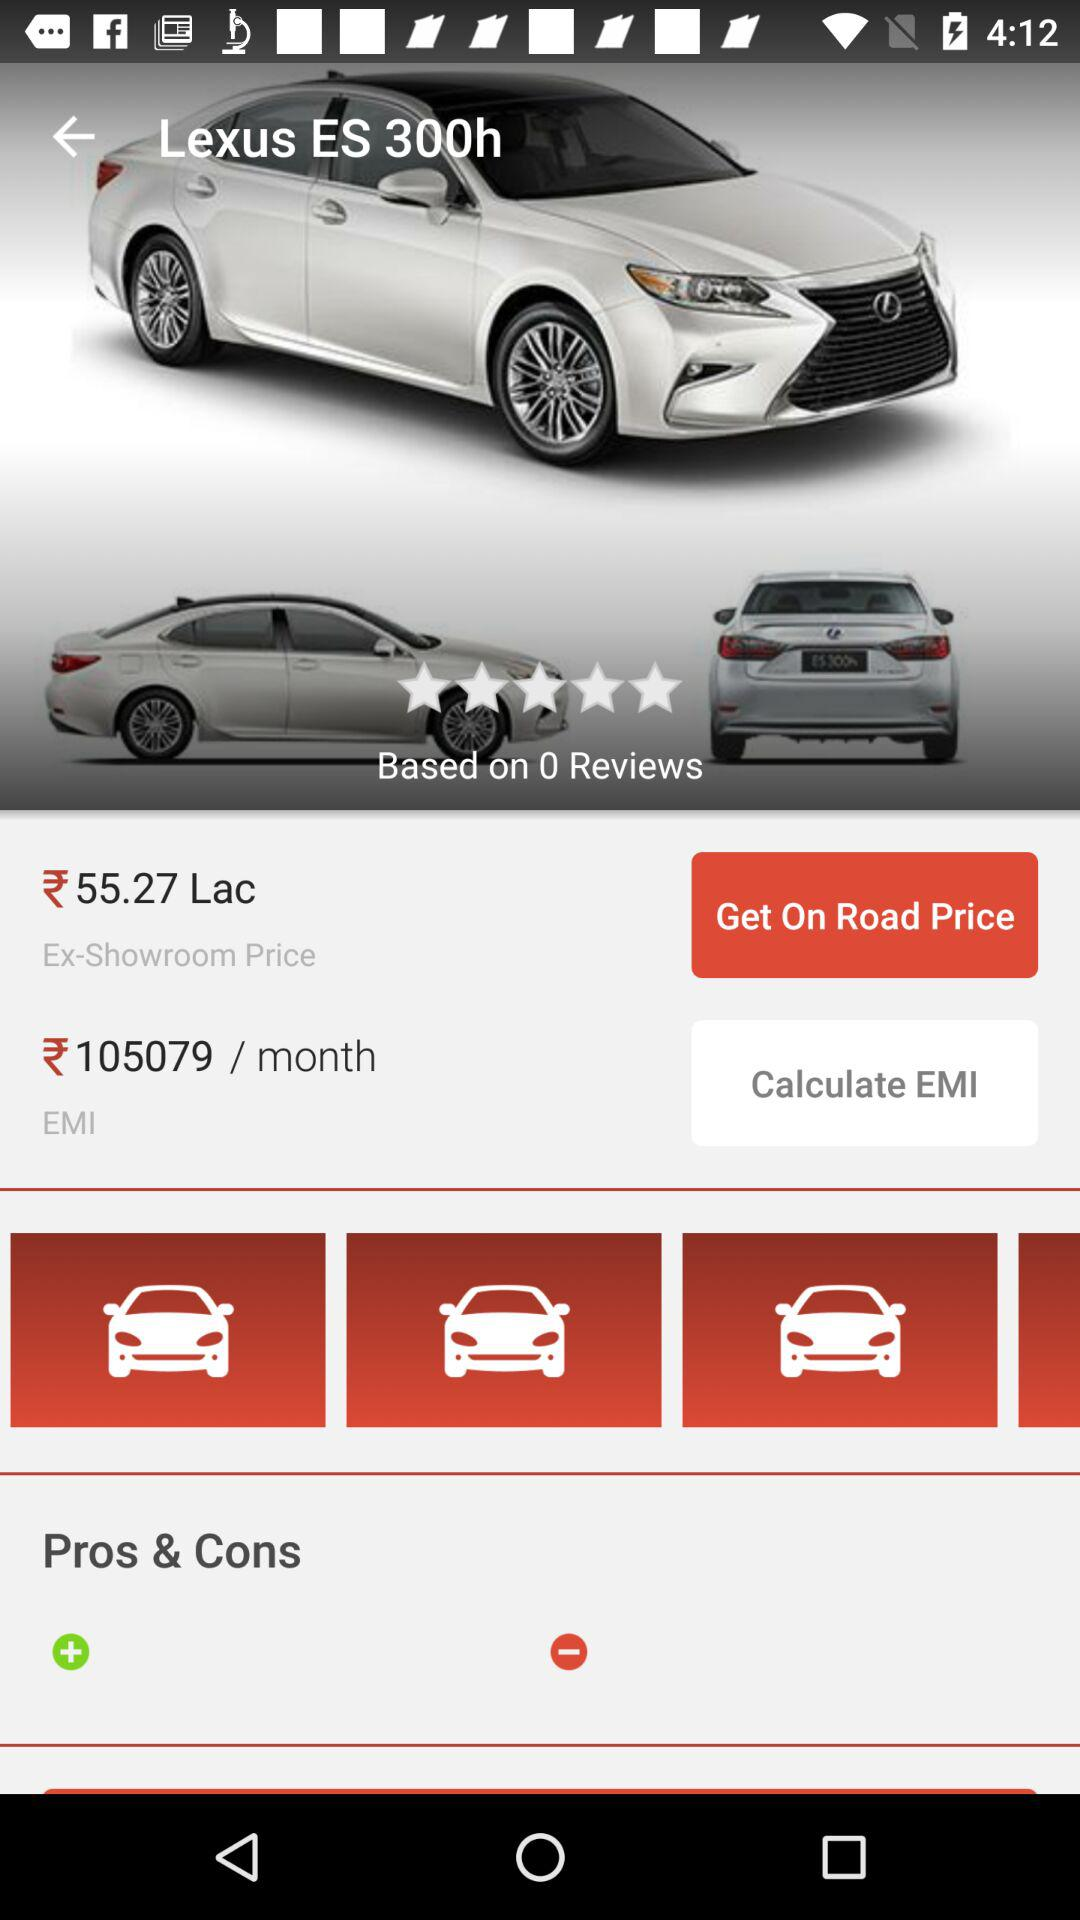How much is the EMI for this car?
Answer the question using a single word or phrase. 105079 / month 